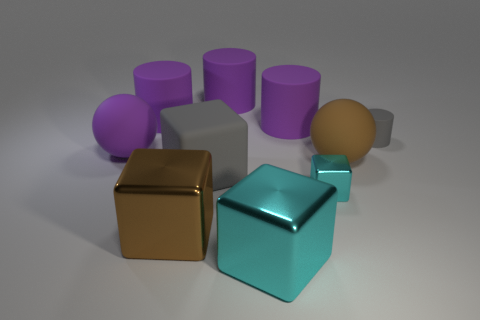The large ball that is to the right of the large ball behind the large matte ball in front of the big purple ball is made of what material?
Give a very brief answer. Rubber. There is a big block that is the same color as the tiny cylinder; what material is it?
Offer a terse response. Rubber. What number of things are either small cyan blocks or tiny cyan cylinders?
Keep it short and to the point. 1. Do the cyan block in front of the tiny cyan metallic cube and the small cyan block have the same material?
Make the answer very short. Yes. What number of objects are either gray rubber objects that are left of the tiny shiny thing or large yellow rubber cubes?
Keep it short and to the point. 1. What color is the block that is made of the same material as the tiny gray cylinder?
Your answer should be compact. Gray. Are there any gray matte cylinders that have the same size as the gray matte block?
Make the answer very short. No. There is a big rubber thing in front of the brown sphere; is its color the same as the tiny cylinder?
Provide a short and direct response. Yes. There is a large thing that is in front of the brown sphere and behind the large brown shiny object; what is its color?
Provide a succinct answer. Gray. There is a cyan shiny object that is the same size as the brown rubber object; what shape is it?
Ensure brevity in your answer.  Cube. 